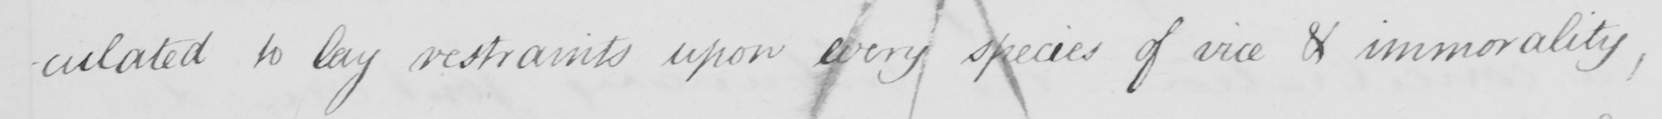What does this handwritten line say? -culated to lay restraints upon every species of vice and immorality, 